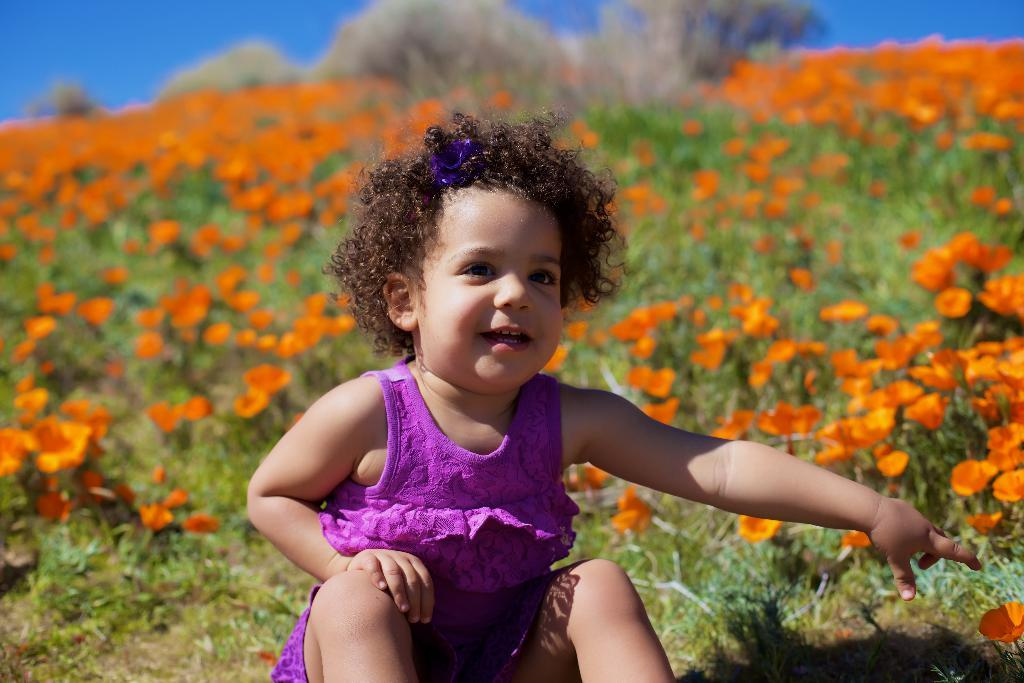What is the child doing in the image? The child is sitting on the ground in the image. What can be seen in the background of the image? There are plants with flowers and the sky visible in the background of the image. What type of dress is the child wearing in the image? The provided facts do not mention the child wearing a dress, so we cannot determine the type of dress from the image. 